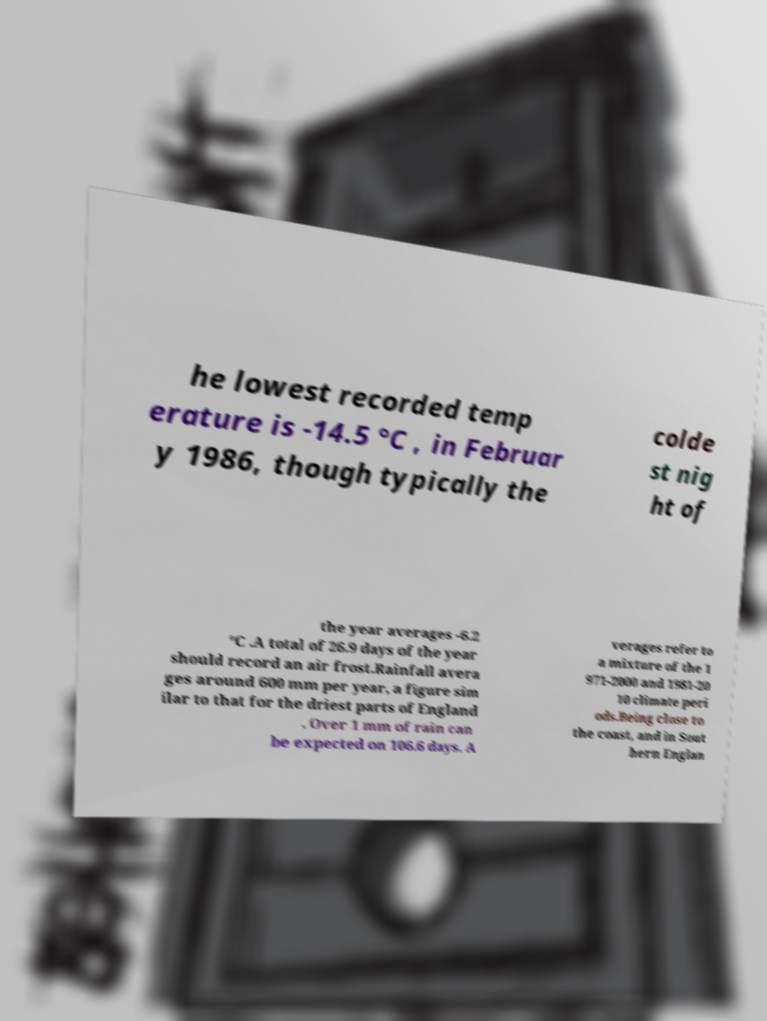I need the written content from this picture converted into text. Can you do that? he lowest recorded temp erature is -14.5 °C , in Februar y 1986, though typically the colde st nig ht of the year averages -6.2 °C .A total of 26.9 days of the year should record an air frost.Rainfall avera ges around 600 mm per year, a figure sim ilar to that for the driest parts of England . Over 1 mm of rain can be expected on 106.6 days. A verages refer to a mixture of the 1 971-2000 and 1981-20 10 climate peri ods.Being close to the coast, and in Sout hern Englan 